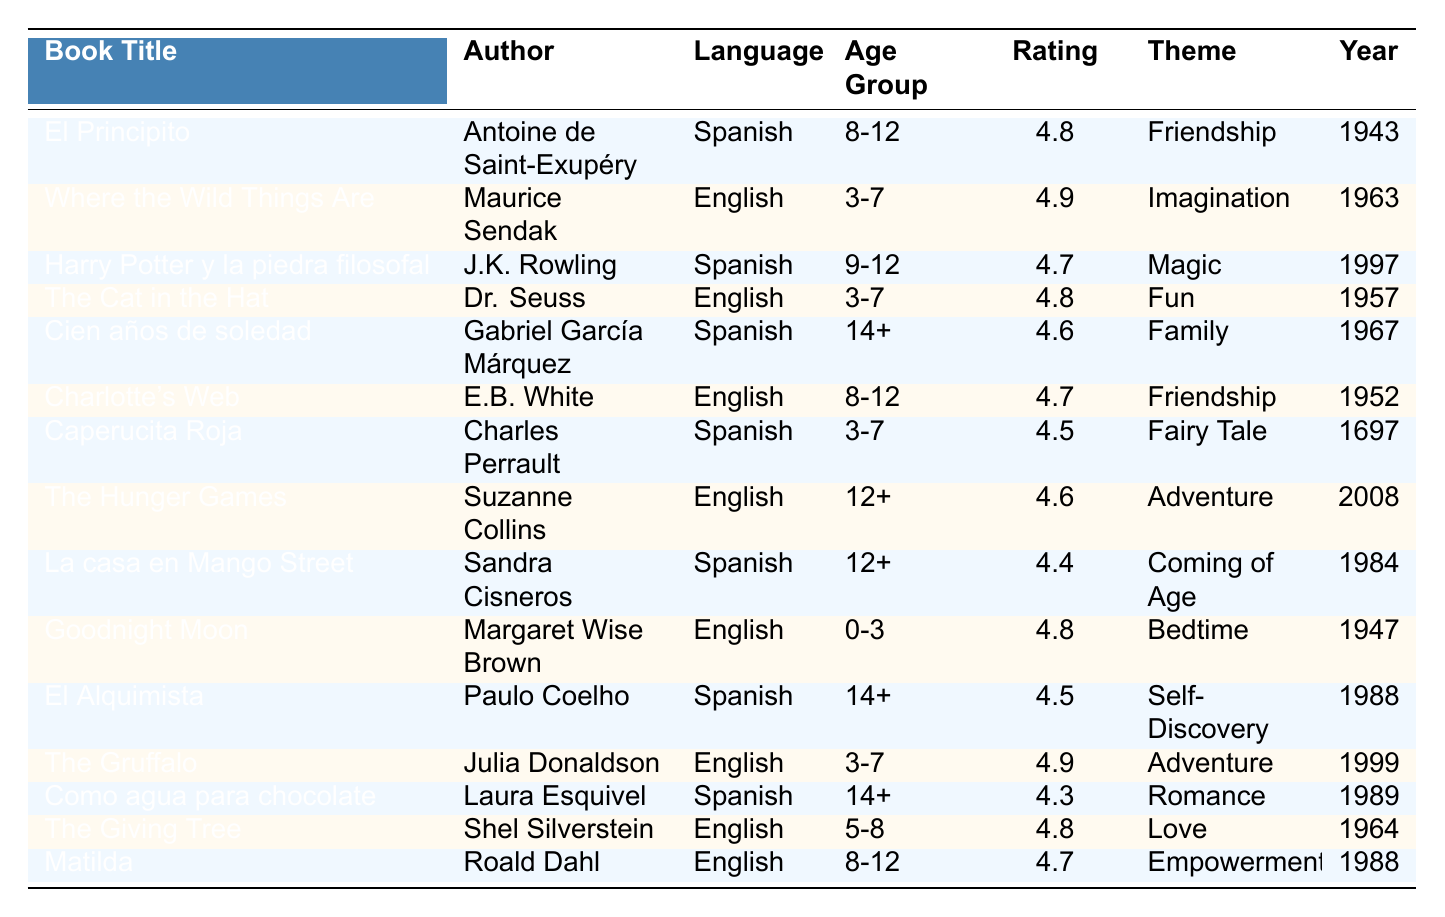What is the highest-rated book in English? The table lists the ratings for each English book. "Where the Wild Things Are" has the highest rating of 4.9.
Answer: 4.9 Which book was published most recently? I look at the publication years listed for each book and find "The Hunger Games," published in 2008.
Answer: 2008 Is "Cien años de soledad" rated higher than "El Alquimista"? "Cien años de soledad" has a rating of 4.6, while "El Alquimista" has a rating of 4.5, so it is rated higher.
Answer: Yes How many books are listed for the age group 3-7? I count the entries in the age group 3-7: "Where the Wild Things Are," "The Cat in the Hat," "Caperucita Roja," "The Gruffalo," giving a total of 4 books.
Answer: 4 What is the average rating for books in Spanish? The ratings for Spanish books are 4.8, 4.7, 4.6, 4.5, 4.4, and 4.3. Summing those gives 28.3, and dividing by 6 gives an average of approximately 4.72.
Answer: 4.72 Which theme appears most frequently among the books? I check the themes across all books and find "Friendship" appears 3 times, more than any other theme, so it is the most frequent.
Answer: Friendship Are there more books written in English or Spanish? Counting the entries, there are 8 English books and 7 Spanish books. Therefore, there are more English books.
Answer: English Which book is the oldest in the list? The oldest book is "Caperucita Roja," published in 1697.
Answer: Caperucita Roja What percentage of the books are rated 4.5 or higher? There are 15 books total, with 12 rated 4.5 or higher. Thus, the percentage is (12/15) * 100 = 80%.
Answer: 80% Is there a book rated exactly 4.4? I scan the ratings and confirm that "La casa en Mango Street" has an exact rating of 4.4.
Answer: Yes 